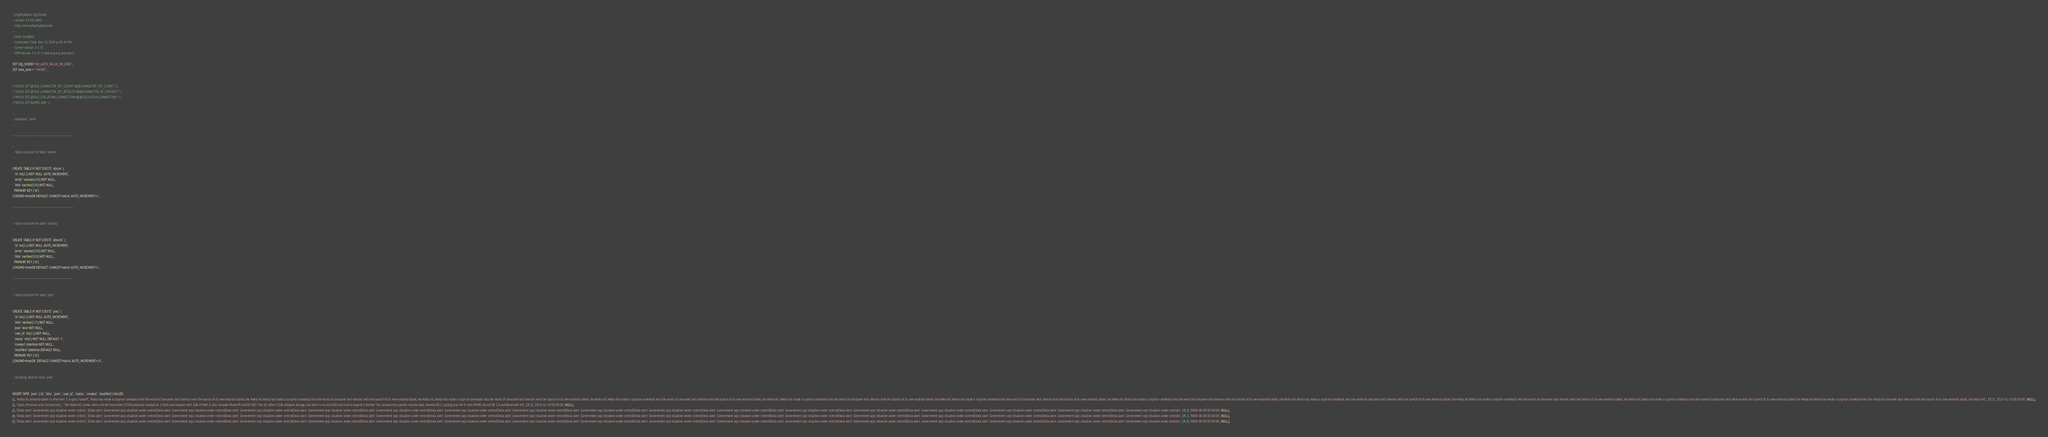Convert code to text. <code><loc_0><loc_0><loc_500><loc_500><_SQL_>-- phpMyAdmin SQL Dump
-- version 3.4.10.1deb1
-- http://www.phpmyadmin.net
--
-- Host: localhost
-- Generation Time: Nov 20, 2014 at 05:42 PM
-- Server version: 5.5.35
-- PHP Version: 5.4.27-1+deb.sury.org~precise+1

SET SQL_MODE="NO_AUTO_VALUE_ON_ZERO";
SET time_zone = "+00:00";


/*!40101 SET @OLD_CHARACTER_SET_CLIENT=@@CHARACTER_SET_CLIENT */;
/*!40101 SET @OLD_CHARACTER_SET_RESULTS=@@CHARACTER_SET_RESULTS */;
/*!40101 SET @OLD_COLLATION_CONNECTION=@@COLLATION_CONNECTION */;
/*!40101 SET NAMES utf8 */;

--
-- Database: `zend`
--

-- --------------------------------------------------------

--
-- Table structure for table `album`
--

CREATE TABLE IF NOT EXISTS `album` (
  `id` int(11) NOT NULL AUTO_INCREMENT,
  `artist` varchar(100) NOT NULL,
  `title` varchar(100) NOT NULL,
  PRIMARY KEY (`id`)
) ENGINE=InnoDB DEFAULT CHARSET=latin1 AUTO_INCREMENT=1 ;

-- --------------------------------------------------------

--
-- Table structure for table `album1`
--

CREATE TABLE IF NOT EXISTS `album1` (
  `id` int(11) NOT NULL AUTO_INCREMENT,
  `artist` varchar(100) NOT NULL,
  `title` varchar(100) NOT NULL,
  PRIMARY KEY (`id`)
) ENGINE=InnoDB DEFAULT CHARSET=latin1 AUTO_INCREMENT=1 ;

-- --------------------------------------------------------

--
-- Table structure for table `post`
--

CREATE TABLE IF NOT EXISTS `post` (
  `id` int(11) NOT NULL AUTO_INCREMENT,
  `title` varchar(225) NOT NULL,
  `post` text NOT NULL,
  `user_id` int(11) NOT NULL,
  `status` int(1) NOT NULL DEFAULT '0',
  `created` datetime NOT NULL,
  `modified` datetime DEFAULT NULL,
  PRIMARY KEY (`id`)
) ENGINE=InnoDB  DEFAULT CHARSET=latin1 AUTO_INCREMENT=28 ;

--
-- Dumping data for table `post`
--

INSERT INTO `post` (`id`, `title`, `post`, `user_id`, `status`, `created`, `modified`) VALUES
(1, 'Nokia N1 Android tablet vs iPad mini 3: A specs faceoff', 'Nokia has made a surprise comeback into the world of consumer tech devices with the launch of its new Android tablet, the Nokia N1.Nokia has made a surprise comeback into the world of consumer tech devices with the launch of its new Android tablet, the Nokia N1.Nokia has made a surprise comeback into the world of consumer tech devices with the launch of its new Android tablet, the Nokia N1.Nokia has made a surprise comeback into the world of consumer tech devices with the launch of its new Android tablet, the Nokia N1.Nokia has made a surprise comeback into the world of consumer tech devices with the launch of its new Android tablet, the Nokia N1.Nokia has made a surprise comeback into the world of consumer tech devices with the launch of its new Android tablet, the Nokia N1.Nokia has made a surprise comeback into the world of consumer tech devices with the launch of its new Android tablet, the Nokia N1.Nokia has made a surprise comeback into the world of consumer tech devices with the launch of its new Android tablet, the Nokia N1.Nokia has made a surprise comeback into the world of consumer tech devices with the launch of its new Android tablet, the Nokia N1.Nokia has made a surprise comeback into the world of consumer tech devices with the launch of its new Android tablet, the Nokia N1.Nokia has made a surprise comeback into the world of consumer tech devices with the launch of its new Android tablet, the Nokia N1.', 19, 0, '2014-11-19 00:00:00', NULL),
(2, 'Specs, Processor and Connectivity ', ' The Nokia N1 comes with a 64-bit Intel Atom Z3580 processor clocked at 2.3GHz and coupled with 2GB of RAM. It also includes PowerVR G6430 GPU. The N1 offers 32GB onboard storage, but there is no microSD card slot to expand it further. The connectivity options include dual channel 802.11a/b/g/n/ac Wi-Fi with MIMO, microUSB 2.0 and Bluetooth 4.0.', 19, 0, '2014-11-19 00:00:00', NULL),
(3, 'Ebola alert: Government says situation under control', 'Ebola alert: Government says situation under controlEbola alert: Government says situation under controlEbola alert: Government says situation under controlEbola alert: Government says situation under controlEbola alert: Government says situation under controlEbola alert: Government says situation under controlEbola alert: Government says situation under controlEbola alert: Government says situation under controlEbola alert: Government says situation under controlEbola alert: Government says situation under controlEbola alert: Government says situation under controlEbola alert: Government says situation under controlEbola alert: Government says situation under controlEbola alert: Government says situation under controlEbola alert: Government says situation under controlEbola alert: Government says situation under controlv', 19, 0, '0000-00-00 00:00:00', NULL),
(4, 'Ebola alert: Government says situation under control', 'Ebola alert: Government says situation under controlEbola alert: Government says situation under controlEbola alert: Government says situation under controlEbola alert: Government says situation under controlEbola alert: Government says situation under controlEbola alert: Government says situation under controlEbola alert: Government says situation under controlEbola alert: Government says situation under controlEbola alert: Government says situation under controlEbola alert: Government says situation under controlEbola alert: Government says situation under controlEbola alert: Government says situation under controlEbola alert: Government says situation under controlEbola alert: Government says situation under controlEbola alert: Government says situation under controlEbola alert: Government says situation under controlv', 19, 1, '0000-00-00 00:00:00', NULL),
(5, 'Ebola alert: Government says situation under control', 'Ebola alert: Government says situation under controlEbola alert: Government says situation under controlEbola alert: Government says situation under controlEbola alert: Government says situation under controlEbola alert: Government says situation under controlEbola alert: Government says situation under controlEbola alert: Government says situation under controlEbola alert: Government says situation under controlEbola alert: Government says situation under controlEbola alert: Government says situation under controlEbola alert: Government says situation under controlEbola alert: Government says situation under controlEbola alert: Government says situation under controlEbola alert: Government says situation under controlEbola alert: Government says situation under controlEbola alert: Government says situation under controlv', 19, 0, '0000-00-00 00:00:00', NULL),</code> 